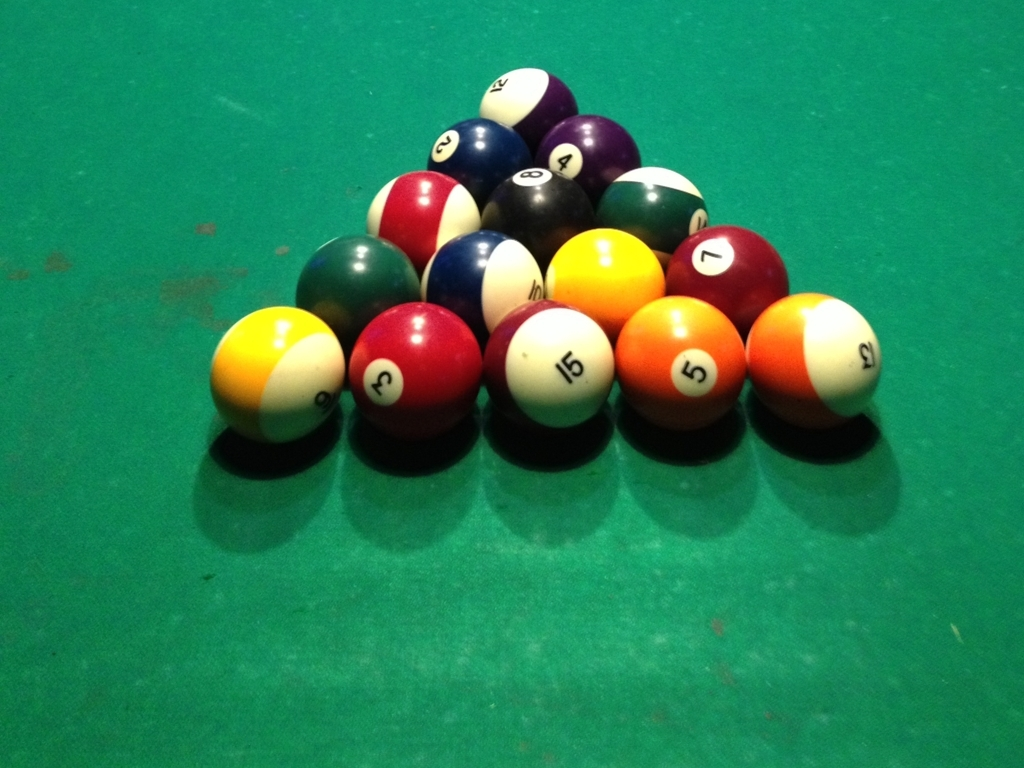What game are these balls typically used for, and how is it played? The balls in the image are used for the game of pool, also known as pocket billiards. It's played on a rectangular table with six pockets and players use cues to strike the cue ball, aiming to pot the other balls in a predetermined order or according to specific game rules. Can you tell me a bit about the strategy involved in pool? Certainly! Pool strategy involves not only making successful shots but also positioning the cue ball favorably for your next shot. Advanced players plan several shots ahead, control the cue ball's spin, and use tactics to block their opponent's next move or even force them to commit fouls. 